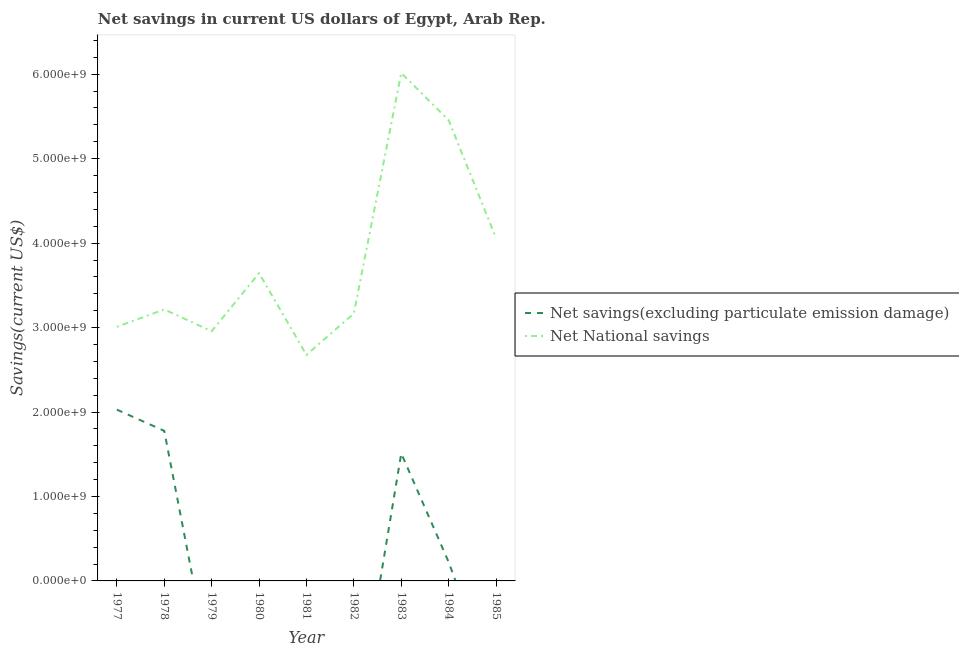How many different coloured lines are there?
Your response must be concise. 2. What is the net national savings in 1984?
Provide a succinct answer. 5.46e+09. Across all years, what is the maximum net savings(excluding particulate emission damage)?
Offer a terse response. 2.03e+09. Across all years, what is the minimum net savings(excluding particulate emission damage)?
Your answer should be compact. 0. What is the total net national savings in the graph?
Your answer should be compact. 3.42e+1. What is the difference between the net national savings in 1981 and that in 1985?
Keep it short and to the point. -1.38e+09. What is the difference between the net savings(excluding particulate emission damage) in 1980 and the net national savings in 1984?
Give a very brief answer. -5.46e+09. What is the average net savings(excluding particulate emission damage) per year?
Your answer should be very brief. 6.15e+08. In the year 1977, what is the difference between the net national savings and net savings(excluding particulate emission damage)?
Make the answer very short. 9.81e+08. What is the ratio of the net national savings in 1982 to that in 1985?
Provide a succinct answer. 0.78. Is the net national savings in 1980 less than that in 1981?
Make the answer very short. No. Is the difference between the net national savings in 1977 and 1983 greater than the difference between the net savings(excluding particulate emission damage) in 1977 and 1983?
Ensure brevity in your answer.  No. What is the difference between the highest and the second highest net savings(excluding particulate emission damage)?
Provide a short and direct response. 2.51e+08. What is the difference between the highest and the lowest net national savings?
Provide a short and direct response. 3.34e+09. Is the sum of the net national savings in 1978 and 1985 greater than the maximum net savings(excluding particulate emission damage) across all years?
Give a very brief answer. Yes. Does the net savings(excluding particulate emission damage) monotonically increase over the years?
Offer a terse response. No. Is the net savings(excluding particulate emission damage) strictly less than the net national savings over the years?
Your answer should be compact. Yes. How many years are there in the graph?
Provide a short and direct response. 9. What is the difference between two consecutive major ticks on the Y-axis?
Keep it short and to the point. 1.00e+09. Are the values on the major ticks of Y-axis written in scientific E-notation?
Keep it short and to the point. Yes. Does the graph contain any zero values?
Your answer should be very brief. Yes. Does the graph contain grids?
Offer a terse response. No. How many legend labels are there?
Make the answer very short. 2. How are the legend labels stacked?
Your answer should be compact. Vertical. What is the title of the graph?
Your response must be concise. Net savings in current US dollars of Egypt, Arab Rep. What is the label or title of the X-axis?
Your answer should be very brief. Year. What is the label or title of the Y-axis?
Offer a very short reply. Savings(current US$). What is the Savings(current US$) in Net savings(excluding particulate emission damage) in 1977?
Offer a very short reply. 2.03e+09. What is the Savings(current US$) of Net National savings in 1977?
Your response must be concise. 3.01e+09. What is the Savings(current US$) of Net savings(excluding particulate emission damage) in 1978?
Your answer should be compact. 1.78e+09. What is the Savings(current US$) in Net National savings in 1978?
Offer a terse response. 3.21e+09. What is the Savings(current US$) in Net savings(excluding particulate emission damage) in 1979?
Offer a very short reply. 0. What is the Savings(current US$) in Net National savings in 1979?
Your answer should be compact. 2.96e+09. What is the Savings(current US$) of Net savings(excluding particulate emission damage) in 1980?
Your response must be concise. 0. What is the Savings(current US$) of Net National savings in 1980?
Give a very brief answer. 3.64e+09. What is the Savings(current US$) in Net National savings in 1981?
Your response must be concise. 2.68e+09. What is the Savings(current US$) of Net National savings in 1982?
Ensure brevity in your answer.  3.17e+09. What is the Savings(current US$) of Net savings(excluding particulate emission damage) in 1983?
Your response must be concise. 1.51e+09. What is the Savings(current US$) of Net National savings in 1983?
Offer a terse response. 6.01e+09. What is the Savings(current US$) in Net savings(excluding particulate emission damage) in 1984?
Keep it short and to the point. 2.23e+08. What is the Savings(current US$) of Net National savings in 1984?
Provide a short and direct response. 5.46e+09. What is the Savings(current US$) of Net savings(excluding particulate emission damage) in 1985?
Ensure brevity in your answer.  0. What is the Savings(current US$) of Net National savings in 1985?
Offer a very short reply. 4.06e+09. Across all years, what is the maximum Savings(current US$) in Net savings(excluding particulate emission damage)?
Keep it short and to the point. 2.03e+09. Across all years, what is the maximum Savings(current US$) in Net National savings?
Keep it short and to the point. 6.01e+09. Across all years, what is the minimum Savings(current US$) of Net savings(excluding particulate emission damage)?
Provide a succinct answer. 0. Across all years, what is the minimum Savings(current US$) of Net National savings?
Offer a terse response. 2.68e+09. What is the total Savings(current US$) in Net savings(excluding particulate emission damage) in the graph?
Make the answer very short. 5.54e+09. What is the total Savings(current US$) of Net National savings in the graph?
Make the answer very short. 3.42e+1. What is the difference between the Savings(current US$) of Net savings(excluding particulate emission damage) in 1977 and that in 1978?
Your response must be concise. 2.51e+08. What is the difference between the Savings(current US$) of Net National savings in 1977 and that in 1978?
Your answer should be very brief. -2.05e+08. What is the difference between the Savings(current US$) in Net National savings in 1977 and that in 1979?
Provide a short and direct response. 5.24e+07. What is the difference between the Savings(current US$) of Net National savings in 1977 and that in 1980?
Provide a succinct answer. -6.35e+08. What is the difference between the Savings(current US$) of Net National savings in 1977 and that in 1981?
Offer a very short reply. 3.33e+08. What is the difference between the Savings(current US$) of Net National savings in 1977 and that in 1982?
Your answer should be compact. -1.58e+08. What is the difference between the Savings(current US$) in Net savings(excluding particulate emission damage) in 1977 and that in 1983?
Ensure brevity in your answer.  5.18e+08. What is the difference between the Savings(current US$) of Net National savings in 1977 and that in 1983?
Your answer should be compact. -3.00e+09. What is the difference between the Savings(current US$) of Net savings(excluding particulate emission damage) in 1977 and that in 1984?
Provide a short and direct response. 1.81e+09. What is the difference between the Savings(current US$) in Net National savings in 1977 and that in 1984?
Offer a terse response. -2.45e+09. What is the difference between the Savings(current US$) in Net National savings in 1977 and that in 1985?
Offer a terse response. -1.05e+09. What is the difference between the Savings(current US$) of Net National savings in 1978 and that in 1979?
Make the answer very short. 2.58e+08. What is the difference between the Savings(current US$) of Net National savings in 1978 and that in 1980?
Your answer should be very brief. -4.30e+08. What is the difference between the Savings(current US$) of Net National savings in 1978 and that in 1981?
Provide a short and direct response. 5.38e+08. What is the difference between the Savings(current US$) in Net National savings in 1978 and that in 1982?
Your answer should be compact. 4.76e+07. What is the difference between the Savings(current US$) of Net savings(excluding particulate emission damage) in 1978 and that in 1983?
Ensure brevity in your answer.  2.67e+08. What is the difference between the Savings(current US$) in Net National savings in 1978 and that in 1983?
Provide a short and direct response. -2.80e+09. What is the difference between the Savings(current US$) in Net savings(excluding particulate emission damage) in 1978 and that in 1984?
Give a very brief answer. 1.55e+09. What is the difference between the Savings(current US$) of Net National savings in 1978 and that in 1984?
Provide a short and direct response. -2.24e+09. What is the difference between the Savings(current US$) of Net National savings in 1978 and that in 1985?
Your answer should be compact. -8.43e+08. What is the difference between the Savings(current US$) of Net National savings in 1979 and that in 1980?
Provide a short and direct response. -6.87e+08. What is the difference between the Savings(current US$) in Net National savings in 1979 and that in 1981?
Keep it short and to the point. 2.80e+08. What is the difference between the Savings(current US$) of Net National savings in 1979 and that in 1982?
Keep it short and to the point. -2.10e+08. What is the difference between the Savings(current US$) in Net National savings in 1979 and that in 1983?
Give a very brief answer. -3.06e+09. What is the difference between the Savings(current US$) of Net National savings in 1979 and that in 1984?
Provide a succinct answer. -2.50e+09. What is the difference between the Savings(current US$) in Net National savings in 1979 and that in 1985?
Provide a short and direct response. -1.10e+09. What is the difference between the Savings(current US$) of Net National savings in 1980 and that in 1981?
Offer a very short reply. 9.68e+08. What is the difference between the Savings(current US$) of Net National savings in 1980 and that in 1982?
Offer a very short reply. 4.77e+08. What is the difference between the Savings(current US$) of Net National savings in 1980 and that in 1983?
Your answer should be very brief. -2.37e+09. What is the difference between the Savings(current US$) of Net National savings in 1980 and that in 1984?
Offer a very short reply. -1.81e+09. What is the difference between the Savings(current US$) of Net National savings in 1980 and that in 1985?
Your response must be concise. -4.14e+08. What is the difference between the Savings(current US$) in Net National savings in 1981 and that in 1982?
Give a very brief answer. -4.90e+08. What is the difference between the Savings(current US$) in Net National savings in 1981 and that in 1983?
Offer a very short reply. -3.34e+09. What is the difference between the Savings(current US$) in Net National savings in 1981 and that in 1984?
Your answer should be very brief. -2.78e+09. What is the difference between the Savings(current US$) in Net National savings in 1981 and that in 1985?
Make the answer very short. -1.38e+09. What is the difference between the Savings(current US$) of Net National savings in 1982 and that in 1983?
Make the answer very short. -2.85e+09. What is the difference between the Savings(current US$) in Net National savings in 1982 and that in 1984?
Give a very brief answer. -2.29e+09. What is the difference between the Savings(current US$) in Net National savings in 1982 and that in 1985?
Your answer should be compact. -8.91e+08. What is the difference between the Savings(current US$) in Net savings(excluding particulate emission damage) in 1983 and that in 1984?
Your answer should be very brief. 1.29e+09. What is the difference between the Savings(current US$) of Net National savings in 1983 and that in 1984?
Your answer should be compact. 5.59e+08. What is the difference between the Savings(current US$) in Net National savings in 1983 and that in 1985?
Offer a terse response. 1.96e+09. What is the difference between the Savings(current US$) of Net National savings in 1984 and that in 1985?
Offer a terse response. 1.40e+09. What is the difference between the Savings(current US$) in Net savings(excluding particulate emission damage) in 1977 and the Savings(current US$) in Net National savings in 1978?
Provide a short and direct response. -1.19e+09. What is the difference between the Savings(current US$) of Net savings(excluding particulate emission damage) in 1977 and the Savings(current US$) of Net National savings in 1979?
Your answer should be compact. -9.29e+08. What is the difference between the Savings(current US$) of Net savings(excluding particulate emission damage) in 1977 and the Savings(current US$) of Net National savings in 1980?
Offer a very short reply. -1.62e+09. What is the difference between the Savings(current US$) in Net savings(excluding particulate emission damage) in 1977 and the Savings(current US$) in Net National savings in 1981?
Ensure brevity in your answer.  -6.48e+08. What is the difference between the Savings(current US$) in Net savings(excluding particulate emission damage) in 1977 and the Savings(current US$) in Net National savings in 1982?
Give a very brief answer. -1.14e+09. What is the difference between the Savings(current US$) in Net savings(excluding particulate emission damage) in 1977 and the Savings(current US$) in Net National savings in 1983?
Offer a very short reply. -3.99e+09. What is the difference between the Savings(current US$) in Net savings(excluding particulate emission damage) in 1977 and the Savings(current US$) in Net National savings in 1984?
Your answer should be very brief. -3.43e+09. What is the difference between the Savings(current US$) in Net savings(excluding particulate emission damage) in 1977 and the Savings(current US$) in Net National savings in 1985?
Give a very brief answer. -2.03e+09. What is the difference between the Savings(current US$) of Net savings(excluding particulate emission damage) in 1978 and the Savings(current US$) of Net National savings in 1979?
Your answer should be very brief. -1.18e+09. What is the difference between the Savings(current US$) in Net savings(excluding particulate emission damage) in 1978 and the Savings(current US$) in Net National savings in 1980?
Your answer should be compact. -1.87e+09. What is the difference between the Savings(current US$) in Net savings(excluding particulate emission damage) in 1978 and the Savings(current US$) in Net National savings in 1981?
Your answer should be compact. -8.99e+08. What is the difference between the Savings(current US$) of Net savings(excluding particulate emission damage) in 1978 and the Savings(current US$) of Net National savings in 1982?
Give a very brief answer. -1.39e+09. What is the difference between the Savings(current US$) in Net savings(excluding particulate emission damage) in 1978 and the Savings(current US$) in Net National savings in 1983?
Provide a succinct answer. -4.24e+09. What is the difference between the Savings(current US$) of Net savings(excluding particulate emission damage) in 1978 and the Savings(current US$) of Net National savings in 1984?
Your answer should be compact. -3.68e+09. What is the difference between the Savings(current US$) of Net savings(excluding particulate emission damage) in 1978 and the Savings(current US$) of Net National savings in 1985?
Keep it short and to the point. -2.28e+09. What is the difference between the Savings(current US$) in Net savings(excluding particulate emission damage) in 1983 and the Savings(current US$) in Net National savings in 1984?
Give a very brief answer. -3.95e+09. What is the difference between the Savings(current US$) in Net savings(excluding particulate emission damage) in 1983 and the Savings(current US$) in Net National savings in 1985?
Your response must be concise. -2.55e+09. What is the difference between the Savings(current US$) of Net savings(excluding particulate emission damage) in 1984 and the Savings(current US$) of Net National savings in 1985?
Offer a very short reply. -3.84e+09. What is the average Savings(current US$) in Net savings(excluding particulate emission damage) per year?
Give a very brief answer. 6.15e+08. What is the average Savings(current US$) in Net National savings per year?
Provide a succinct answer. 3.80e+09. In the year 1977, what is the difference between the Savings(current US$) of Net savings(excluding particulate emission damage) and Savings(current US$) of Net National savings?
Give a very brief answer. -9.81e+08. In the year 1978, what is the difference between the Savings(current US$) in Net savings(excluding particulate emission damage) and Savings(current US$) in Net National savings?
Ensure brevity in your answer.  -1.44e+09. In the year 1983, what is the difference between the Savings(current US$) of Net savings(excluding particulate emission damage) and Savings(current US$) of Net National savings?
Provide a short and direct response. -4.50e+09. In the year 1984, what is the difference between the Savings(current US$) in Net savings(excluding particulate emission damage) and Savings(current US$) in Net National savings?
Offer a terse response. -5.23e+09. What is the ratio of the Savings(current US$) in Net savings(excluding particulate emission damage) in 1977 to that in 1978?
Offer a very short reply. 1.14. What is the ratio of the Savings(current US$) in Net National savings in 1977 to that in 1978?
Provide a succinct answer. 0.94. What is the ratio of the Savings(current US$) of Net National savings in 1977 to that in 1979?
Provide a succinct answer. 1.02. What is the ratio of the Savings(current US$) of Net National savings in 1977 to that in 1980?
Your answer should be compact. 0.83. What is the ratio of the Savings(current US$) of Net National savings in 1977 to that in 1981?
Your response must be concise. 1.12. What is the ratio of the Savings(current US$) in Net National savings in 1977 to that in 1982?
Provide a succinct answer. 0.95. What is the ratio of the Savings(current US$) of Net savings(excluding particulate emission damage) in 1977 to that in 1983?
Give a very brief answer. 1.34. What is the ratio of the Savings(current US$) in Net National savings in 1977 to that in 1983?
Your answer should be compact. 0.5. What is the ratio of the Savings(current US$) of Net savings(excluding particulate emission damage) in 1977 to that in 1984?
Make the answer very short. 9.1. What is the ratio of the Savings(current US$) in Net National savings in 1977 to that in 1984?
Give a very brief answer. 0.55. What is the ratio of the Savings(current US$) in Net National savings in 1977 to that in 1985?
Offer a very short reply. 0.74. What is the ratio of the Savings(current US$) of Net National savings in 1978 to that in 1979?
Offer a very short reply. 1.09. What is the ratio of the Savings(current US$) of Net National savings in 1978 to that in 1980?
Offer a very short reply. 0.88. What is the ratio of the Savings(current US$) of Net National savings in 1978 to that in 1981?
Your response must be concise. 1.2. What is the ratio of the Savings(current US$) of Net savings(excluding particulate emission damage) in 1978 to that in 1983?
Keep it short and to the point. 1.18. What is the ratio of the Savings(current US$) of Net National savings in 1978 to that in 1983?
Keep it short and to the point. 0.53. What is the ratio of the Savings(current US$) of Net savings(excluding particulate emission damage) in 1978 to that in 1984?
Make the answer very short. 7.97. What is the ratio of the Savings(current US$) of Net National savings in 1978 to that in 1984?
Keep it short and to the point. 0.59. What is the ratio of the Savings(current US$) of Net National savings in 1978 to that in 1985?
Make the answer very short. 0.79. What is the ratio of the Savings(current US$) of Net National savings in 1979 to that in 1980?
Your response must be concise. 0.81. What is the ratio of the Savings(current US$) in Net National savings in 1979 to that in 1981?
Ensure brevity in your answer.  1.1. What is the ratio of the Savings(current US$) in Net National savings in 1979 to that in 1982?
Offer a terse response. 0.93. What is the ratio of the Savings(current US$) in Net National savings in 1979 to that in 1983?
Provide a succinct answer. 0.49. What is the ratio of the Savings(current US$) in Net National savings in 1979 to that in 1984?
Provide a short and direct response. 0.54. What is the ratio of the Savings(current US$) of Net National savings in 1979 to that in 1985?
Your answer should be very brief. 0.73. What is the ratio of the Savings(current US$) of Net National savings in 1980 to that in 1981?
Offer a very short reply. 1.36. What is the ratio of the Savings(current US$) of Net National savings in 1980 to that in 1982?
Offer a terse response. 1.15. What is the ratio of the Savings(current US$) of Net National savings in 1980 to that in 1983?
Make the answer very short. 0.61. What is the ratio of the Savings(current US$) of Net National savings in 1980 to that in 1984?
Your answer should be compact. 0.67. What is the ratio of the Savings(current US$) in Net National savings in 1980 to that in 1985?
Your answer should be compact. 0.9. What is the ratio of the Savings(current US$) of Net National savings in 1981 to that in 1982?
Offer a terse response. 0.85. What is the ratio of the Savings(current US$) of Net National savings in 1981 to that in 1983?
Your response must be concise. 0.45. What is the ratio of the Savings(current US$) of Net National savings in 1981 to that in 1984?
Your response must be concise. 0.49. What is the ratio of the Savings(current US$) in Net National savings in 1981 to that in 1985?
Your answer should be compact. 0.66. What is the ratio of the Savings(current US$) in Net National savings in 1982 to that in 1983?
Your answer should be compact. 0.53. What is the ratio of the Savings(current US$) of Net National savings in 1982 to that in 1984?
Your answer should be very brief. 0.58. What is the ratio of the Savings(current US$) of Net National savings in 1982 to that in 1985?
Offer a very short reply. 0.78. What is the ratio of the Savings(current US$) of Net savings(excluding particulate emission damage) in 1983 to that in 1984?
Offer a terse response. 6.78. What is the ratio of the Savings(current US$) in Net National savings in 1983 to that in 1984?
Your response must be concise. 1.1. What is the ratio of the Savings(current US$) in Net National savings in 1983 to that in 1985?
Give a very brief answer. 1.48. What is the ratio of the Savings(current US$) of Net National savings in 1984 to that in 1985?
Keep it short and to the point. 1.34. What is the difference between the highest and the second highest Savings(current US$) in Net savings(excluding particulate emission damage)?
Ensure brevity in your answer.  2.51e+08. What is the difference between the highest and the second highest Savings(current US$) in Net National savings?
Give a very brief answer. 5.59e+08. What is the difference between the highest and the lowest Savings(current US$) in Net savings(excluding particulate emission damage)?
Provide a succinct answer. 2.03e+09. What is the difference between the highest and the lowest Savings(current US$) in Net National savings?
Offer a terse response. 3.34e+09. 